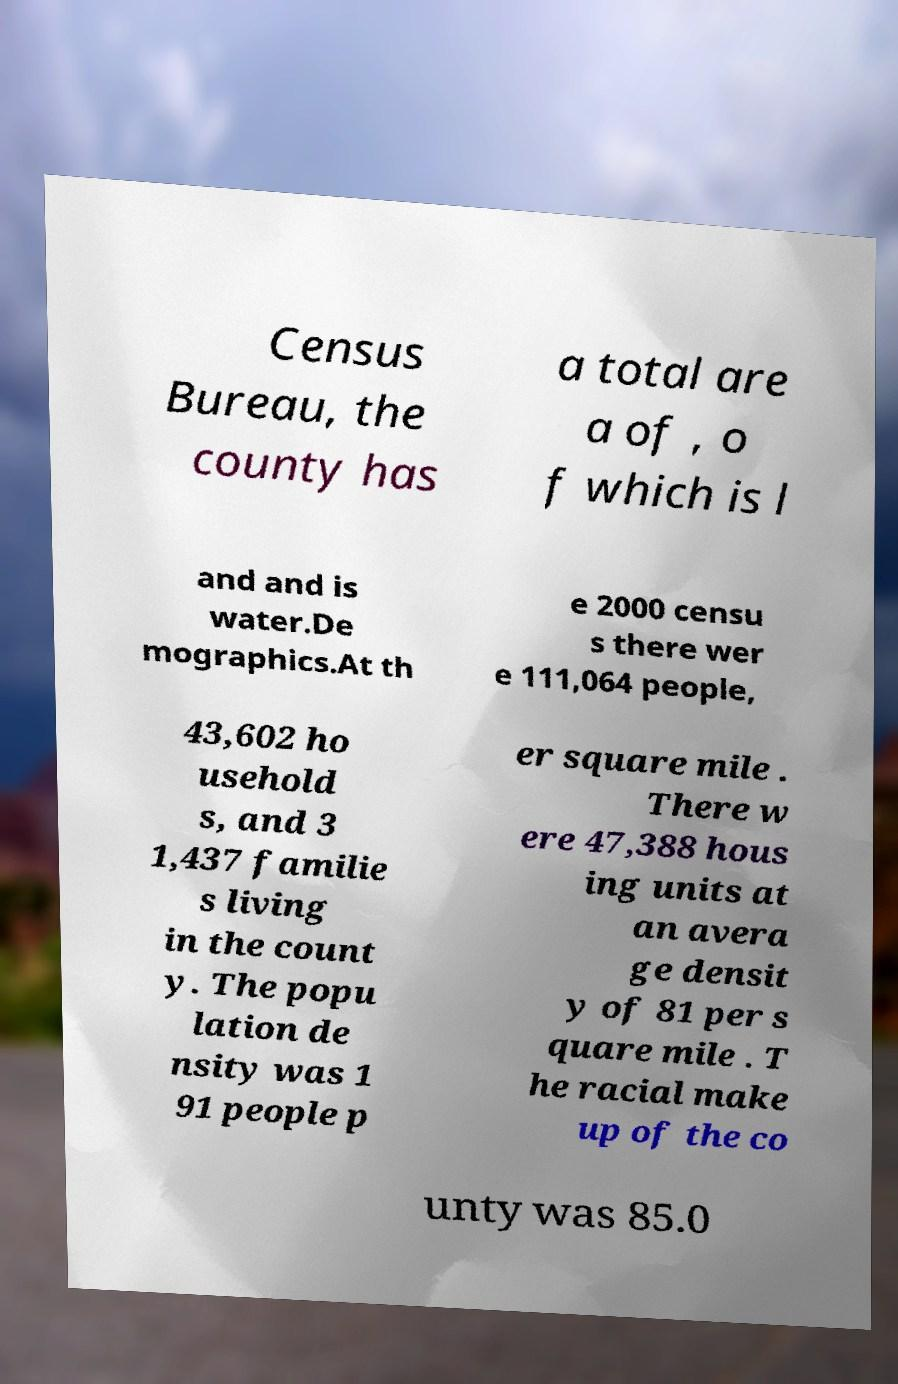For documentation purposes, I need the text within this image transcribed. Could you provide that? Census Bureau, the county has a total are a of , o f which is l and and is water.De mographics.At th e 2000 censu s there wer e 111,064 people, 43,602 ho usehold s, and 3 1,437 familie s living in the count y. The popu lation de nsity was 1 91 people p er square mile . There w ere 47,388 hous ing units at an avera ge densit y of 81 per s quare mile . T he racial make up of the co unty was 85.0 